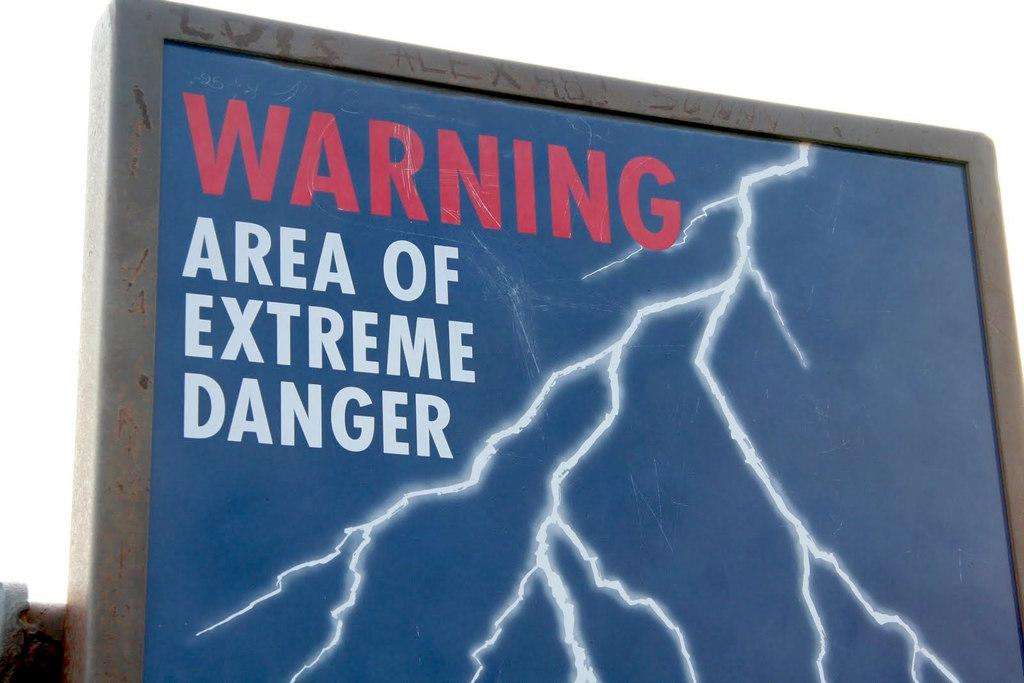<image>
Write a terse but informative summary of the picture. A black and blue sign has the words warning! 